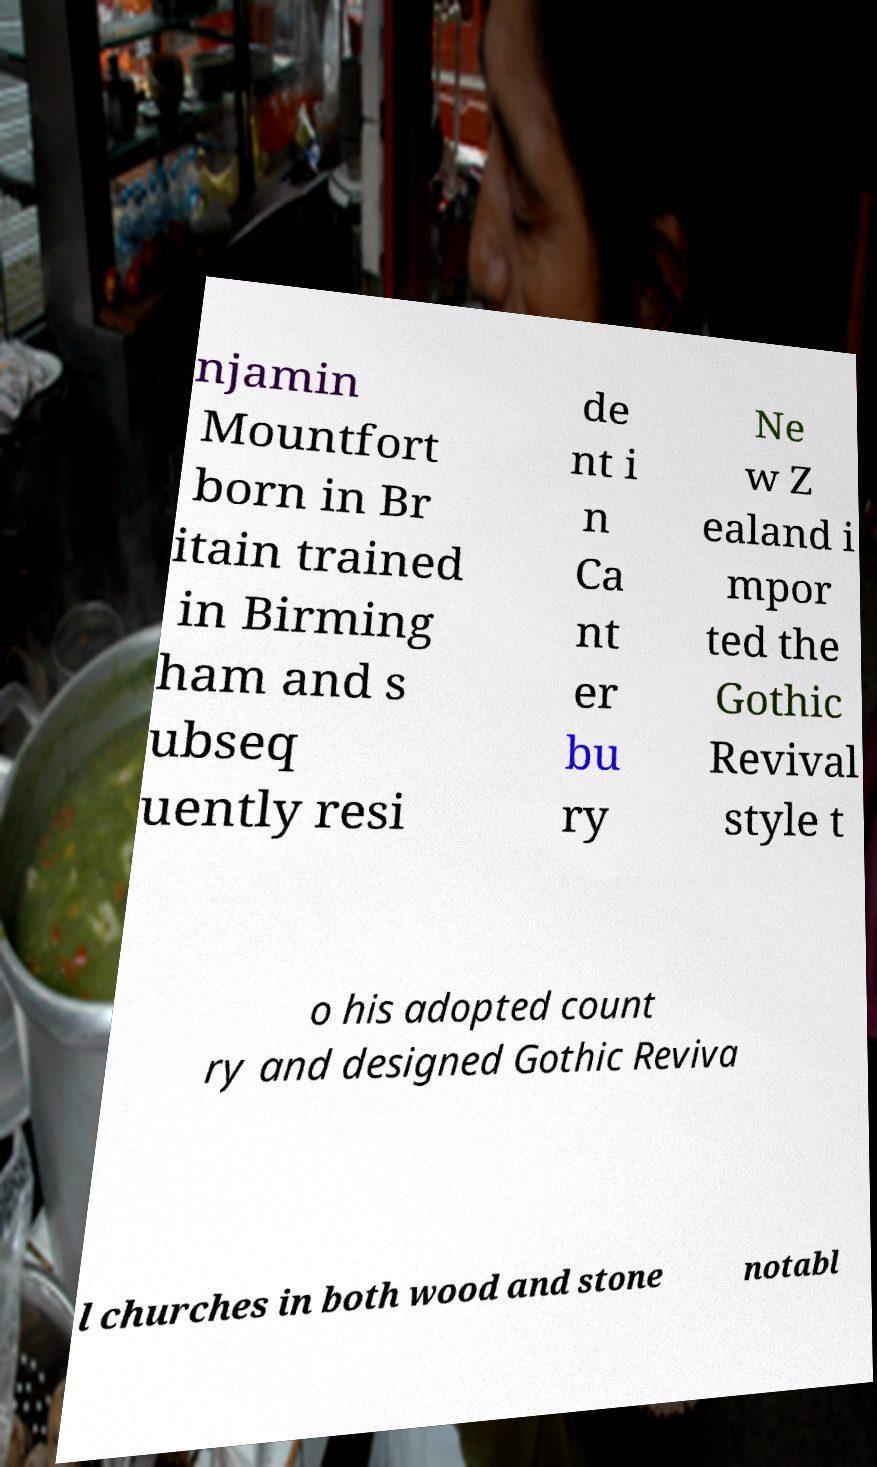What messages or text are displayed in this image? I need them in a readable, typed format. njamin Mountfort born in Br itain trained in Birming ham and s ubseq uently resi de nt i n Ca nt er bu ry Ne w Z ealand i mpor ted the Gothic Revival style t o his adopted count ry and designed Gothic Reviva l churches in both wood and stone notabl 